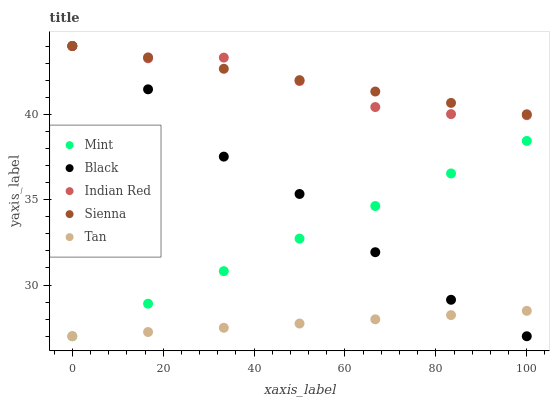Does Tan have the minimum area under the curve?
Answer yes or no. Yes. Does Sienna have the maximum area under the curve?
Answer yes or no. Yes. Does Black have the minimum area under the curve?
Answer yes or no. No. Does Black have the maximum area under the curve?
Answer yes or no. No. Is Sienna the smoothest?
Answer yes or no. Yes. Is Black the roughest?
Answer yes or no. Yes. Is Tan the smoothest?
Answer yes or no. No. Is Tan the roughest?
Answer yes or no. No. Does Black have the lowest value?
Answer yes or no. Yes. Does Indian Red have the lowest value?
Answer yes or no. No. Does Indian Red have the highest value?
Answer yes or no. Yes. Does Tan have the highest value?
Answer yes or no. No. Is Mint less than Sienna?
Answer yes or no. Yes. Is Sienna greater than Mint?
Answer yes or no. Yes. Does Sienna intersect Black?
Answer yes or no. Yes. Is Sienna less than Black?
Answer yes or no. No. Is Sienna greater than Black?
Answer yes or no. No. Does Mint intersect Sienna?
Answer yes or no. No. 